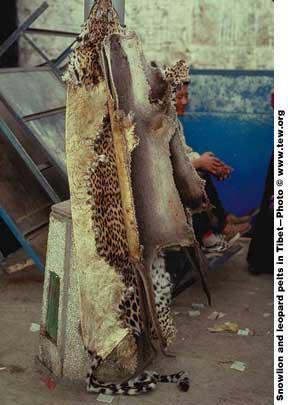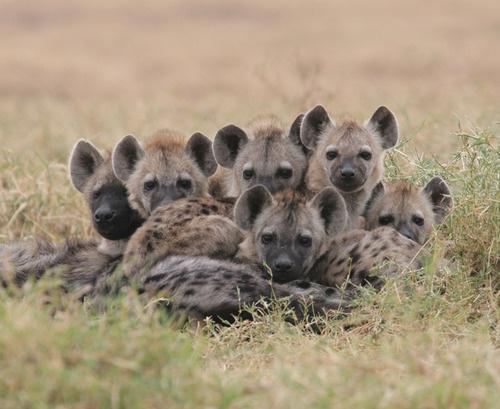The first image is the image on the left, the second image is the image on the right. Given the left and right images, does the statement "The right image has an animal looking to the left." hold true? Answer yes or no. No. The first image is the image on the left, the second image is the image on the right. Given the left and right images, does the statement "At least two prairie dogs are looking straight ahead." hold true? Answer yes or no. Yes. 